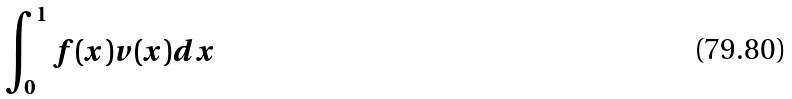Convert formula to latex. <formula><loc_0><loc_0><loc_500><loc_500>\int _ { 0 } ^ { 1 } f ( x ) v ( x ) d x</formula> 